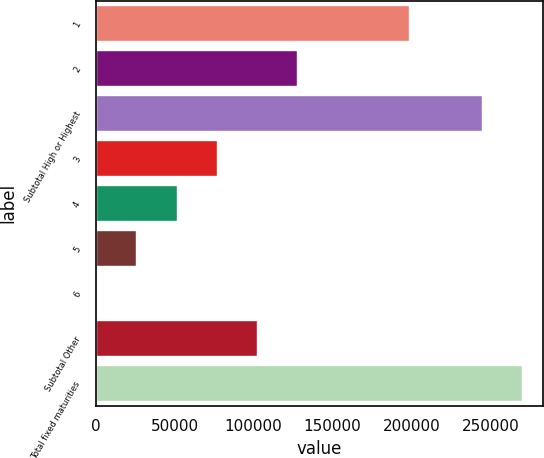<chart> <loc_0><loc_0><loc_500><loc_500><bar_chart><fcel>1<fcel>2<fcel>Subtotal High or Highest<fcel>3<fcel>4<fcel>5<fcel>6<fcel>Subtotal Other<fcel>Total fixed maturities<nl><fcel>198688<fcel>127701<fcel>244572<fcel>76773.8<fcel>51310.2<fcel>25846.6<fcel>383<fcel>102237<fcel>270036<nl></chart> 